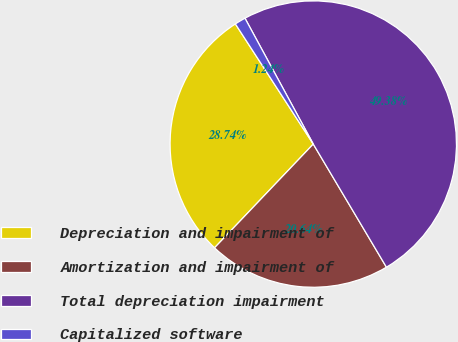<chart> <loc_0><loc_0><loc_500><loc_500><pie_chart><fcel>Depreciation and impairment of<fcel>Amortization and impairment of<fcel>Total depreciation impairment<fcel>Capitalized software<nl><fcel>28.74%<fcel>20.64%<fcel>49.38%<fcel>1.24%<nl></chart> 